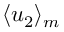Convert formula to latex. <formula><loc_0><loc_0><loc_500><loc_500>\langle u _ { 2 } \rangle _ { m }</formula> 